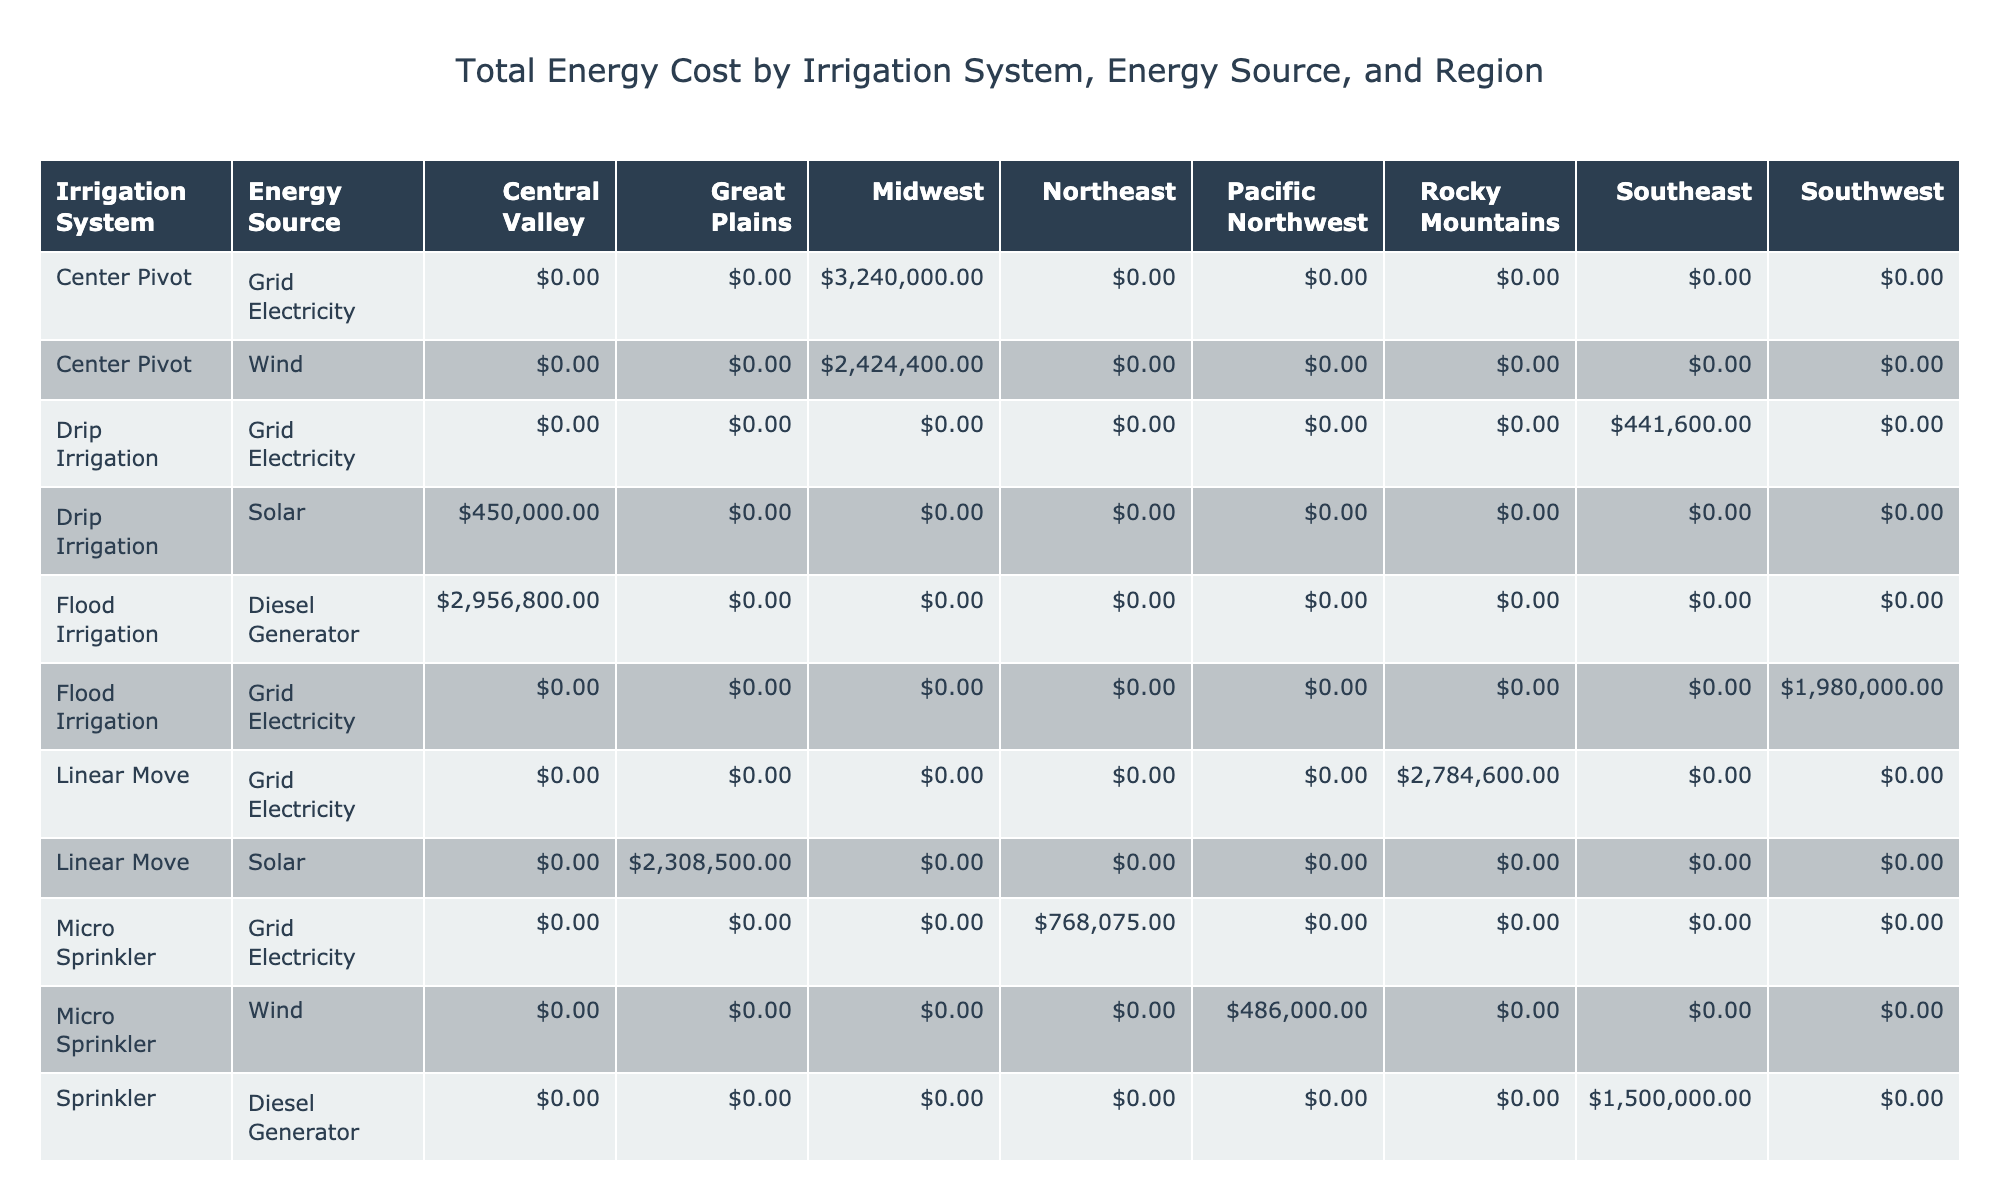What is the total energy cost for Drip Irrigation using Solar energy in the Central Valley? From the table, the energy cost for Drip Irrigation from Solar energy in the Central Valley is displayed as $180,000. This is calculated by taking the energy consumption per acre (150 kWh/acre), multiplying it by the cost per kWh ($0.10), farm size (25 acres), and annual operating hours (1200 hours). The formula is: 150 * 0.10 * 25 * 1200 = $180,000.
Answer: $180,000 Which irrigation system has the highest total energy cost in the Southeast region? The total energy cost for each irrigation system in the Southeast region needs to be compared. For Sprinkler with Diesel Generator, the cost is $210,000; for Drip Irrigation with Grid Electricity, it is $19,200; for Traveling Gun with Grid Electricity, it is $324,000. The highest value is from the Traveling Gun system.
Answer: Traveling Gun What is the average total energy cost for irrigation systems using Wind energy? The total energy costs from the table for Wind energy are $62,400 (Micro Sprinkler) + $56,640 (Center Pivot) + $46,080 (Subsurface Drip) = $165,120. The average is calculated by dividing this sum by the number of systems, which is 3, giving $55,040 as the average cost of Wind energy systems.
Answer: $55,040 True or False: Flood Irrigation has a higher energy cost compared to Drip Irrigation when both use Grid Electricity. For Flood Irrigation with Grid Electricity, the total energy cost is $35,880, while for Drip Irrigation with Grid Electricity it is $19,200. Since $35,880 is greater than $19,200, the statement is true.
Answer: True How much more energy cost does the Center Pivot with Grid Electricity incur compared to Flood Irrigation in the Southwest? The total energy cost for Center Pivot with Grid Electricity is $118,800 and for Flood Irrigation in the Southwest it is $25,120. The difference is calculated as $118,800 - $25,120 = $93,680, indicating that Center Pivot incurs substantially more cost.
Answer: $93,680 